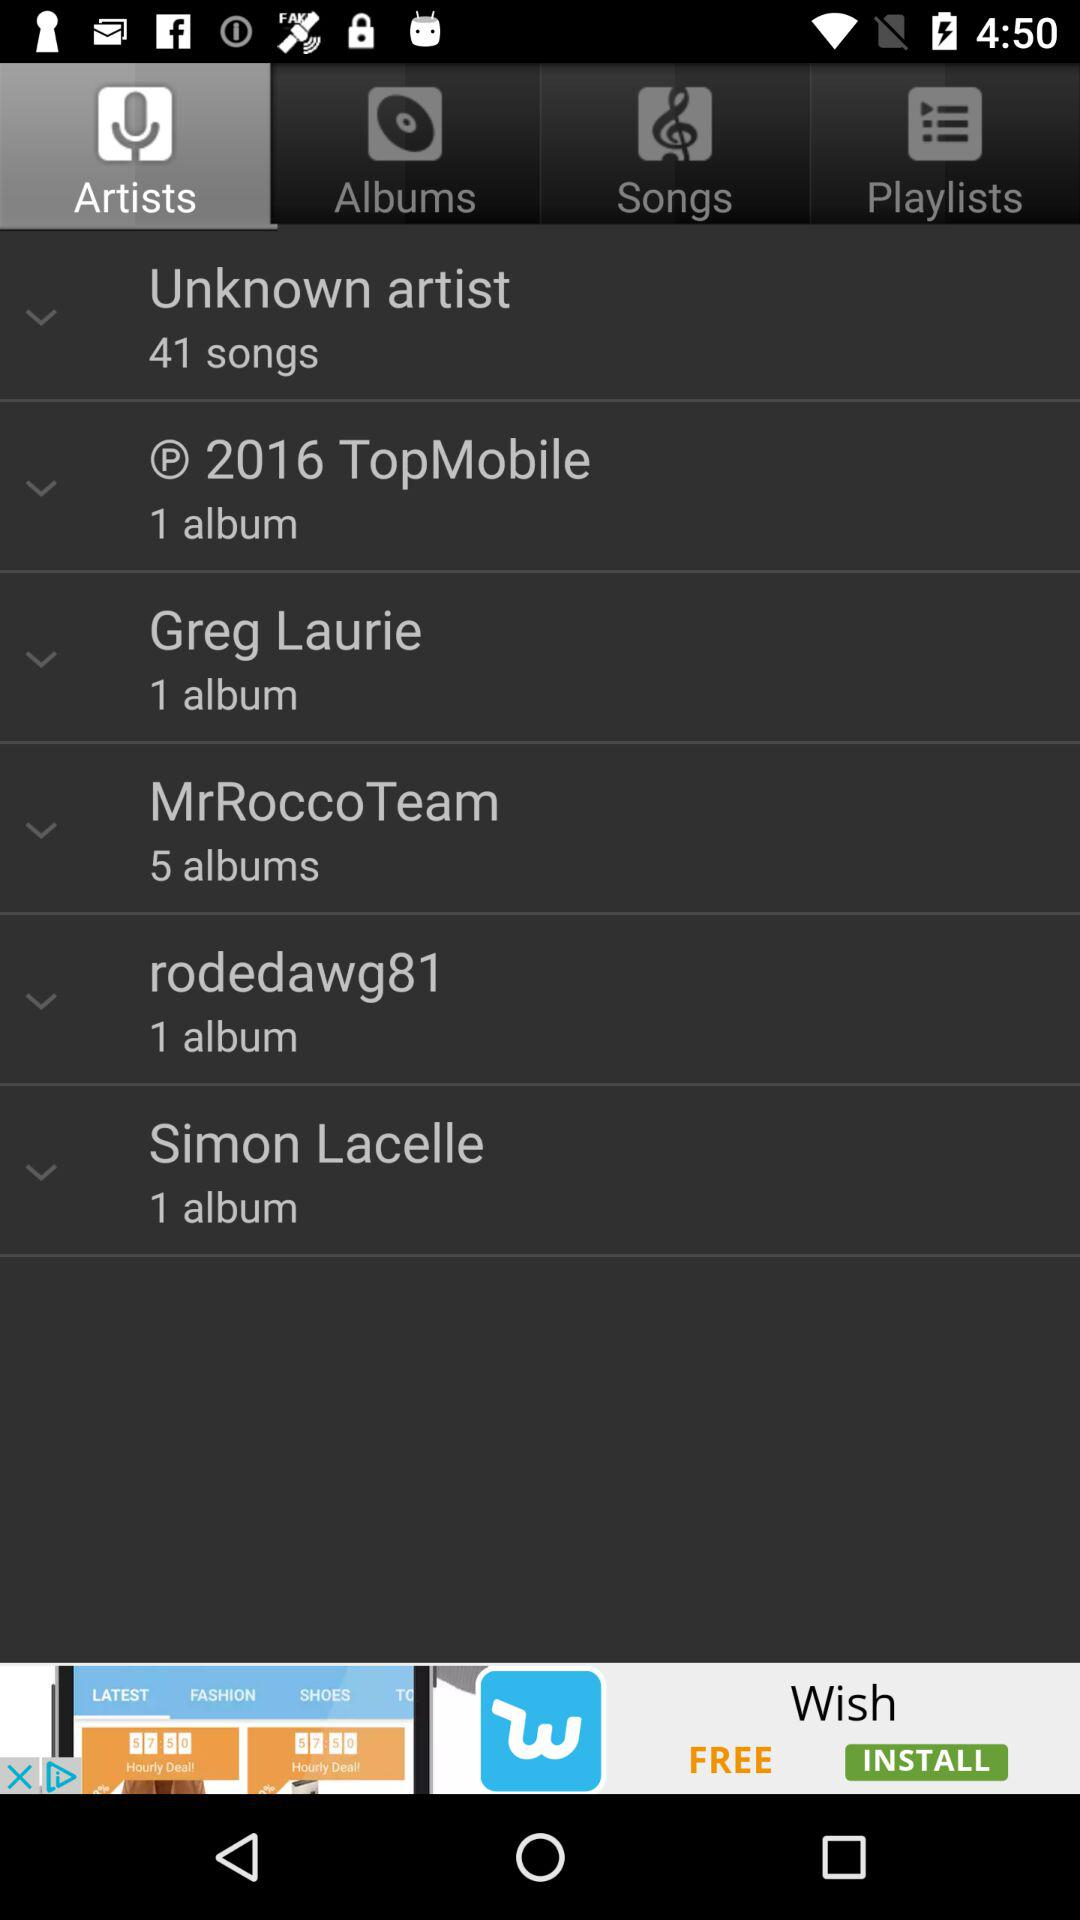How many albums does "MrRoccoTeam" have? "MrRoccoTeam" has 5 albums. 